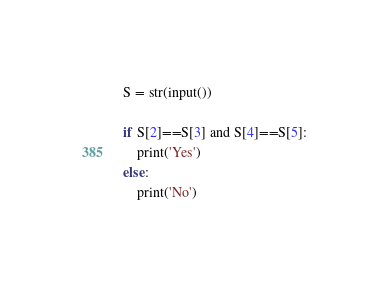<code> <loc_0><loc_0><loc_500><loc_500><_Python_>S = str(input())

if S[2]==S[3] and S[4]==S[5]:
    print('Yes')
else:
    print('No')</code> 